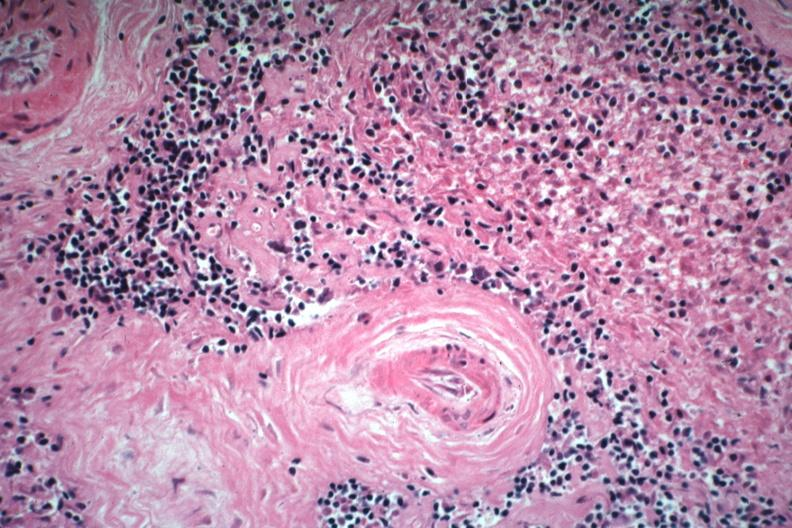s hematologic present?
Answer the question using a single word or phrase. Yes 